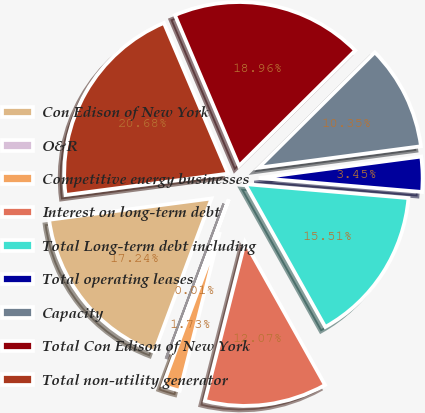Convert chart. <chart><loc_0><loc_0><loc_500><loc_500><pie_chart><fcel>Con Edison of New York<fcel>O&R<fcel>Competitive energy businesses<fcel>Interest on long-term debt<fcel>Total Long-term debt including<fcel>Total operating leases<fcel>Capacity<fcel>Total Con Edison of New York<fcel>Total non-utility generator<nl><fcel>17.24%<fcel>0.01%<fcel>1.73%<fcel>12.07%<fcel>15.51%<fcel>3.45%<fcel>10.35%<fcel>18.96%<fcel>20.68%<nl></chart> 